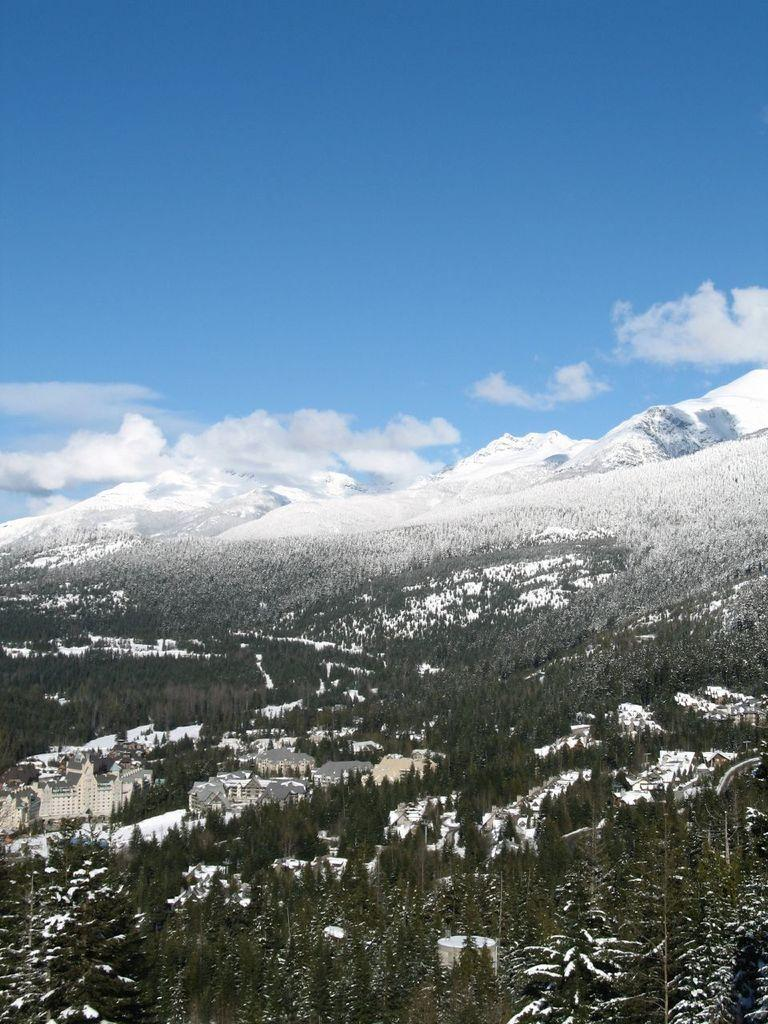What type of natural elements are at the bottom of the image? There are trees and buildings at the bottom of the image. What type of man-made structures are at the bottom of the image? There are buildings at the bottom of the image. What type of geographical features are visible in the background of the image? There are mountains in the background of the image. What type of weather condition is depicted in the background of the image? There is snow in the background of the image. What is visible at the top of the image? The sky is visible at the top of the image. What type of memory is stored in the stove in the image? There is no stove present in the image, and therefore no memory can be stored in it. What type of pancake is being cooked on the mountain in the image? There is no pancake or cooking activity depicted in the image; it features trees, buildings, mountains, snow, and sky. 